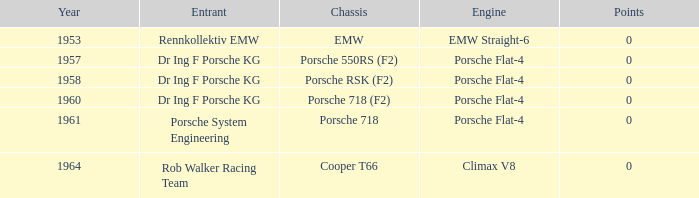What engine did the porsche 718 chassis use? Porsche Flat-4. 